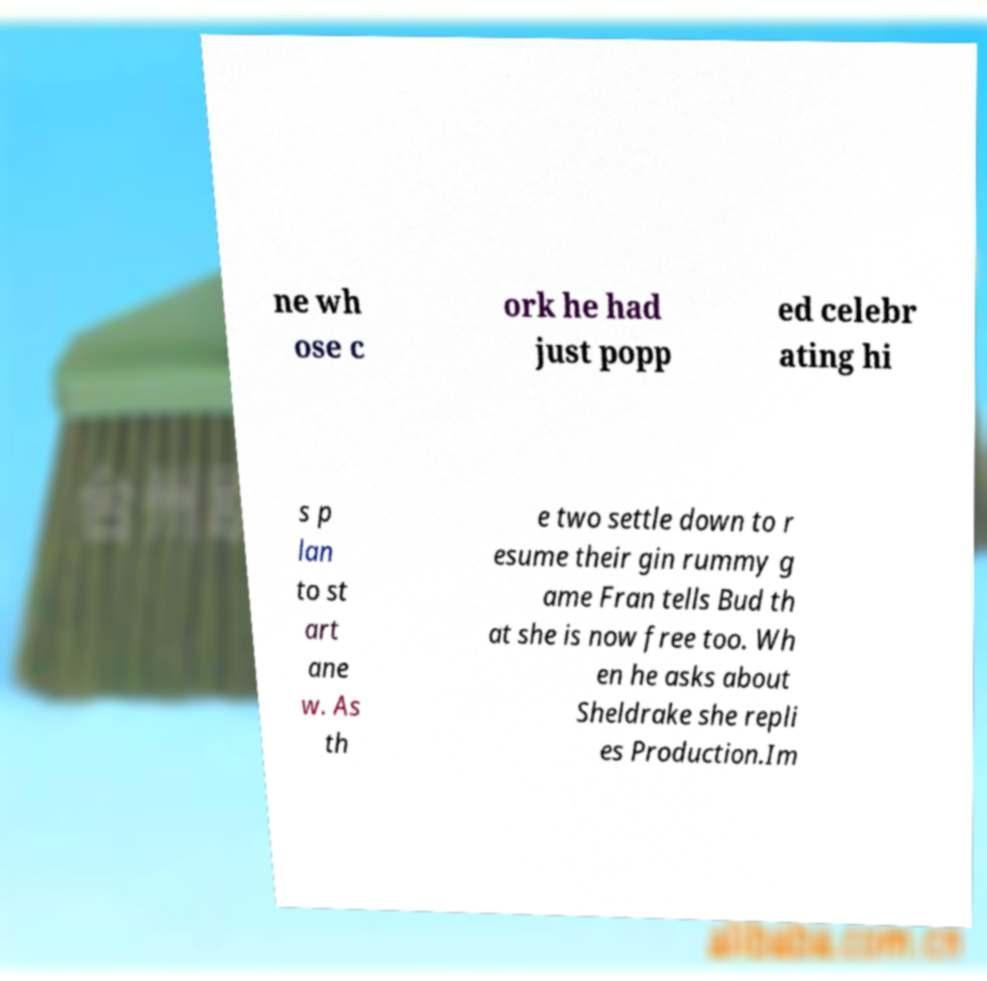Could you extract and type out the text from this image? ne wh ose c ork he had just popp ed celebr ating hi s p lan to st art ane w. As th e two settle down to r esume their gin rummy g ame Fran tells Bud th at she is now free too. Wh en he asks about Sheldrake she repli es Production.Im 